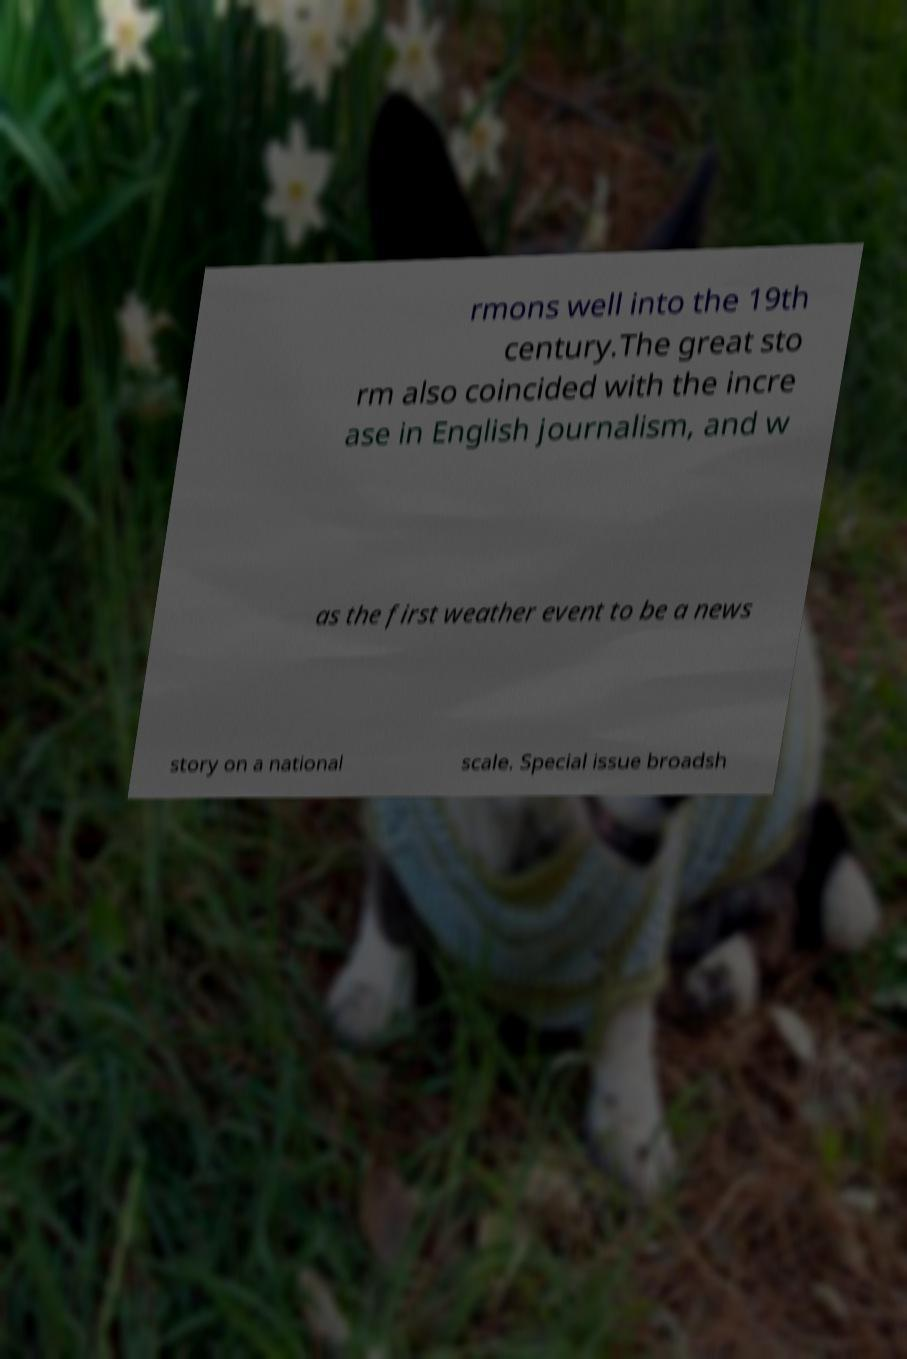Could you extract and type out the text from this image? rmons well into the 19th century.The great sto rm also coincided with the incre ase in English journalism, and w as the first weather event to be a news story on a national scale. Special issue broadsh 